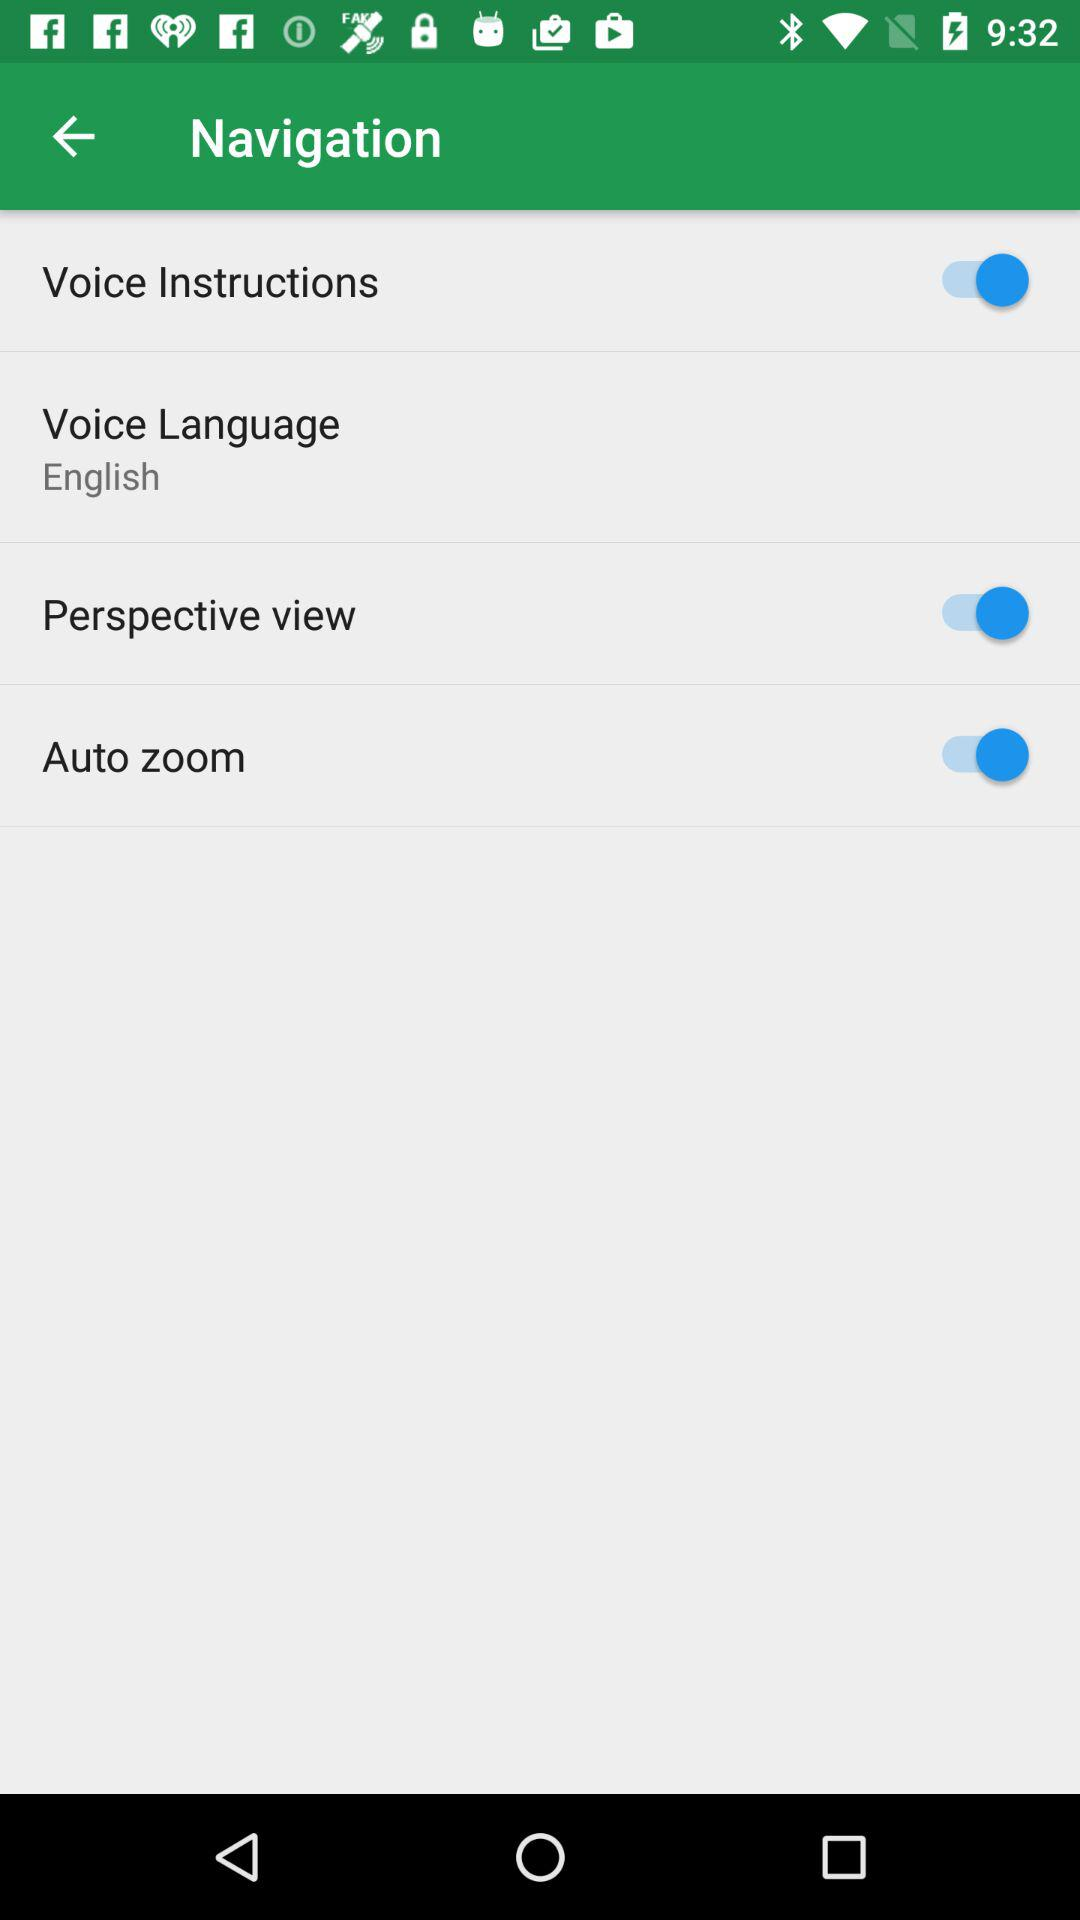What is the status of auto-zoom? The status of auto-zoom is on. 